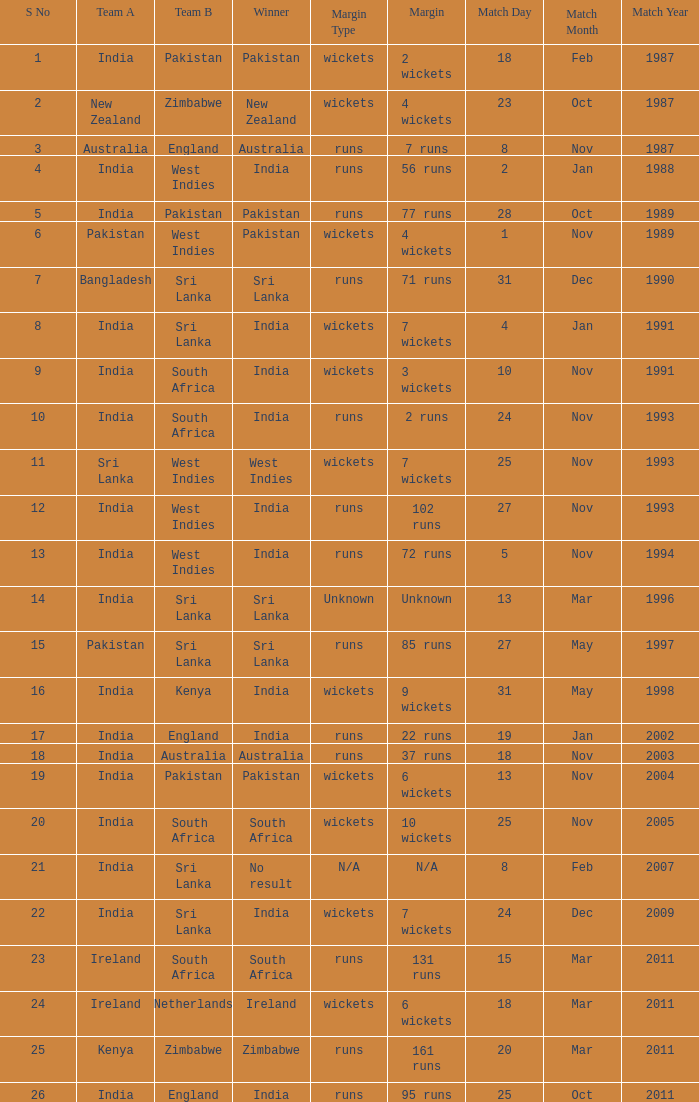What date did the West Indies win the match? 25 Nov 1993. 